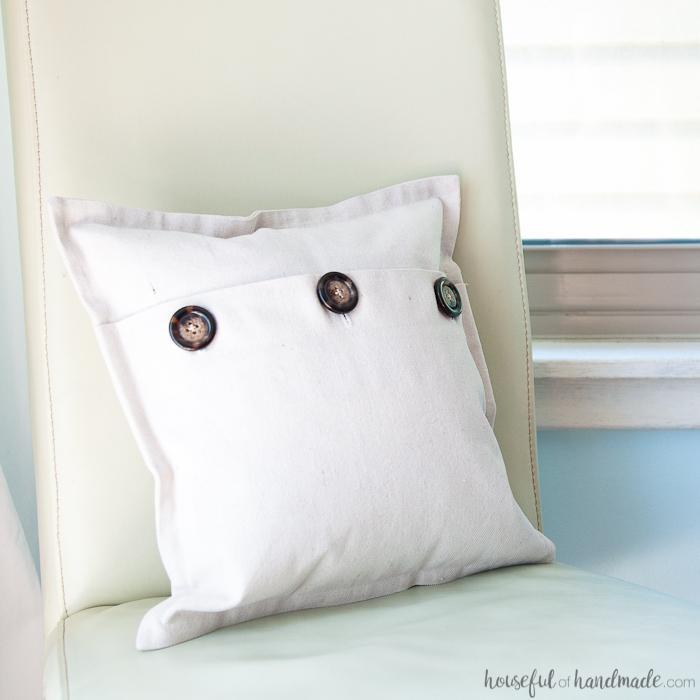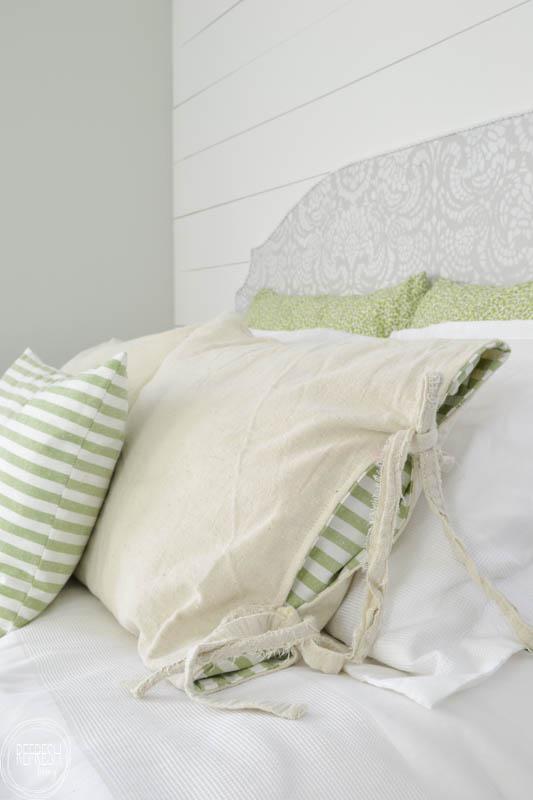The first image is the image on the left, the second image is the image on the right. Examine the images to the left and right. Is the description "One image features a white square pillow with three button closure that is propped against the back of a white chair." accurate? Answer yes or no. Yes. The first image is the image on the left, the second image is the image on the right. For the images shown, is this caption "The pillow in one of the images has three buttons." true? Answer yes or no. Yes. 